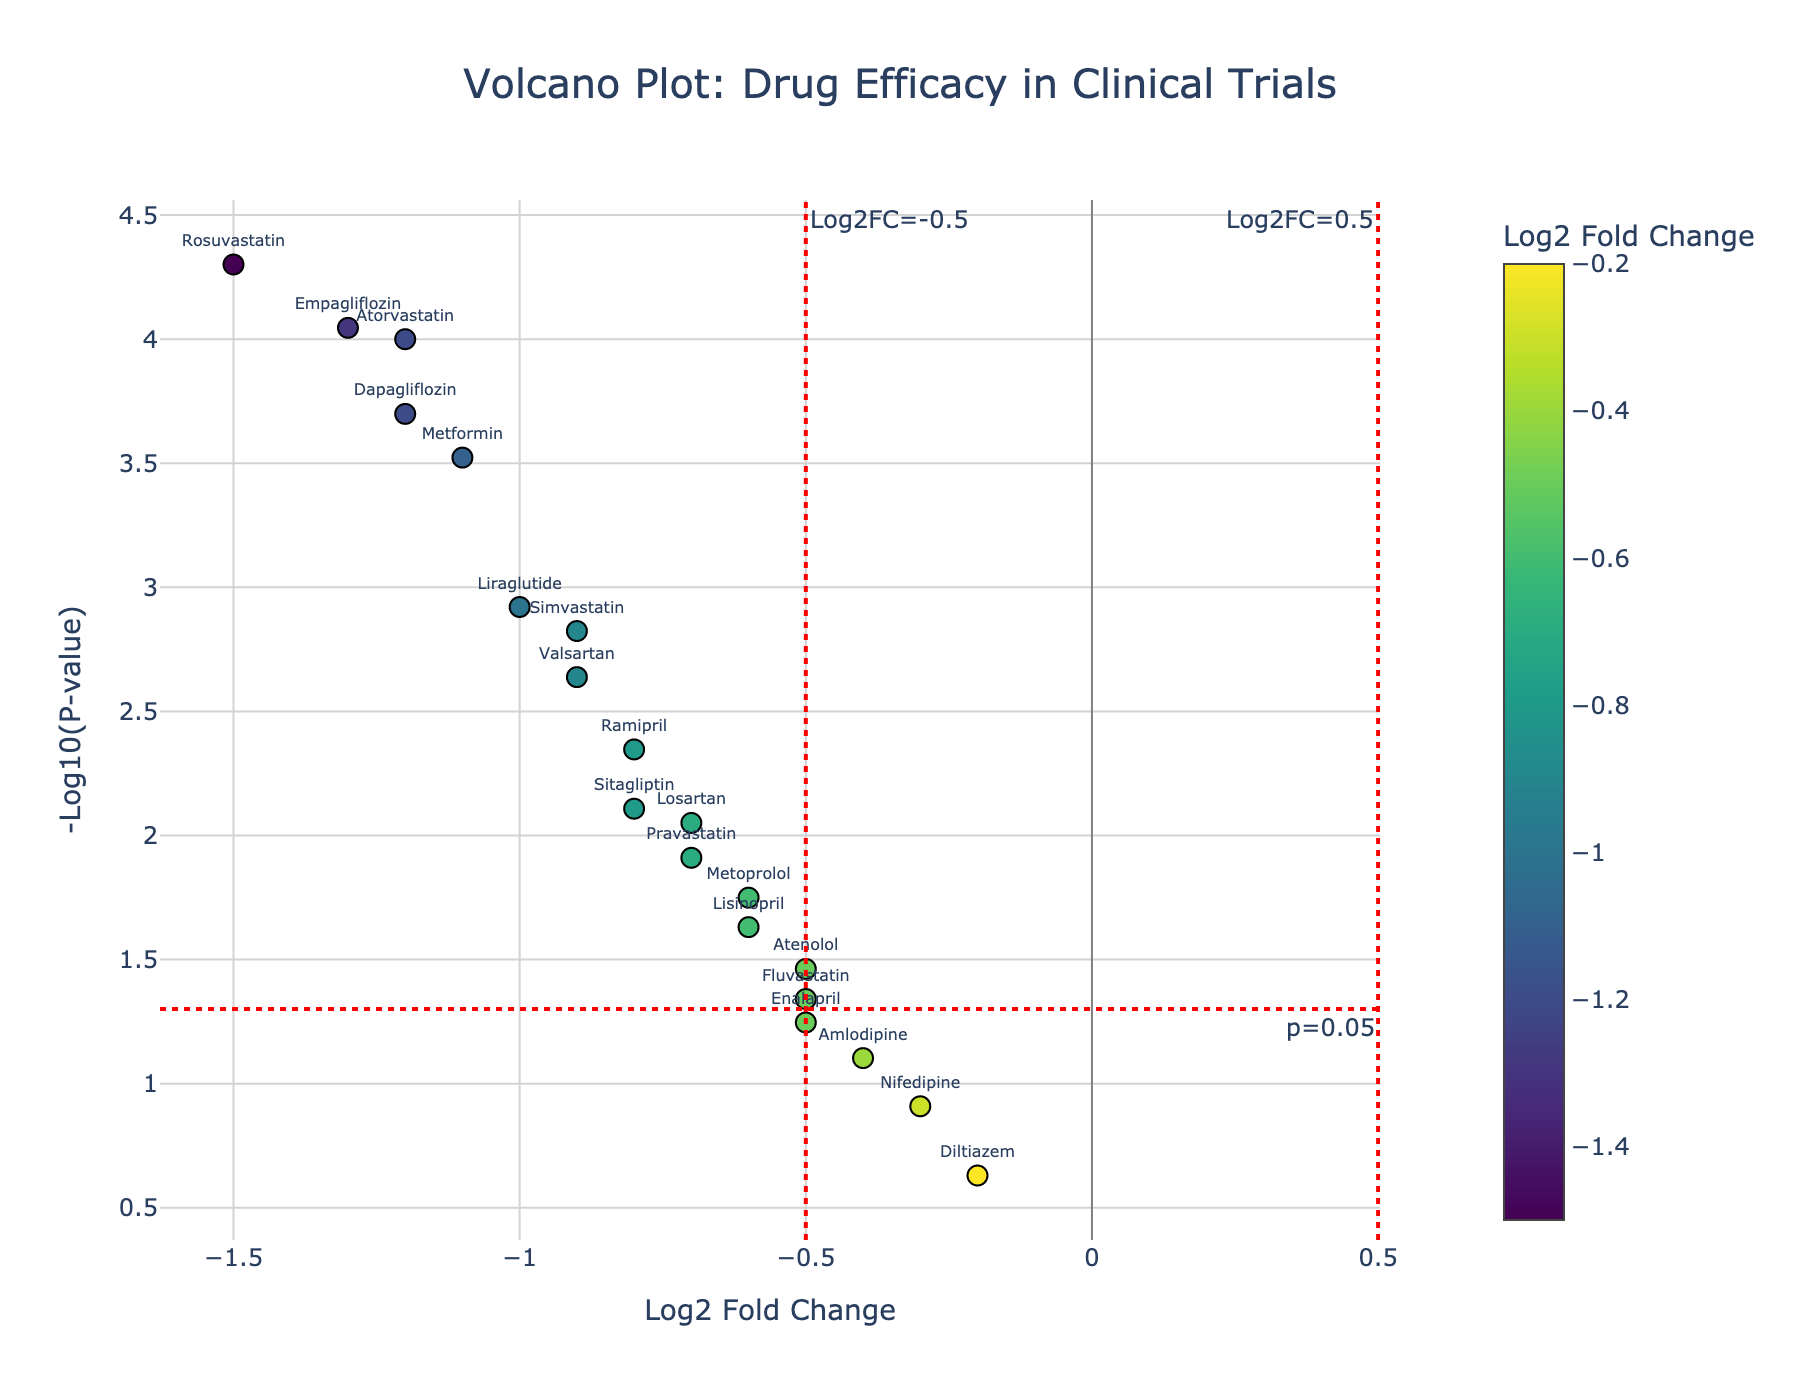What is the title of the Volcano Plot? The title is displayed prominently at the top of the plot. It reads "Volcano Plot: Drug Efficacy in Clinical Trials".
Answer: Volcano Plot: Drug Efficacy in Clinical Trials How many drugs are represented in the plot? Count the number of data points or the number of drug names shown in the plot. There are 20 drugs.
Answer: 20 Which drug has the highest -log10(p-value)? Identify the data point that is highest on the y-axis. Rosuvastatin has the highest -log10(p-value).
Answer: Rosuvastatin What is the log2 fold change for Rosuvastatin, and what does it indicate about its drug efficacy? Locate Rosuvastatin on the plot, its log2 fold change is -1.5. A negative fold-change value indicates a decrease in response.
Answer: -1.5, decrease Which drug has the lowest -log10(p-value) amongst those shown in the plot? Identify the data point that is lowest on the y-axis. Diltiazem has the lowest -log10(p-value).
Answer: Diltiazem Which drugs have a statistically significant p-value threshold of 0.05? Look for drugs that are above the horizontal red dashed line indicating p=0.05. These include Atorvastatin, Simvastatin, Rosuvastatin, Metformin, Sitagliptin, Empagliflozin, Dapagliflozin, Lisinopril, Ramipril, Valsartan, Losartan, Metoprolol, and Atenolol.
Answer: Atorvastatin, Simvastatin, Rosuvastatin, Metformin, Sitagliptin, Empagliflozin, Dapagliflozin, Lisinopril, Ramipril, Valsartan, Losartan, Metoprolol, Atenolol Compare the log2 fold changes of Atorvastatin and Simvastatin. Which one shows a greater change and in what direction? Find the log2 fold changes for both drugs, Atorvastatin is -1.2 and Simvastatin is -0.9. Atorvastatin shows a greater change in the negative direction.
Answer: Atorvastatin, negative What does a -log10(p-value) above 1.3 indicate, and which drugs have this? A -log10(p-value) above 1.3 indicates a p-value less than 0.05, showing statistical significance. Drugs with this are Atorvastatin, Simvastatin, Rosuvastatin, Metformin, Sitagliptin, Empagliflozin, Liraglutide, Dapagliflozin, Lisinopril, Ramipril, Valsartan, and Metoprolol.
Answer: Atorvastatin, Simvastatin, Rosuvastatin, Metformin, Sitagliptin, Empagliflozin, Liraglutide, Dapagliflozin, Lisinopril, Ramipril, Valsartan, Metoprolol Which drugs have log2 fold changes less than -1, and what does this mean? Identify drugs with log2 fold changes less than -1 on the plot. These are Atorvastatin, Rosuvastatin, Metformin, Empagliflozin, and Dapagliflozin. It means all these drugs have a more than 50% decrease in response.
Answer: Atorvastatin, Rosuvastatin, Metformin, Empagliflozin, Dapagliflozin What is the relationship between log2 fold change and p-value in the context of this plot? Generally, drugs with greater log2 fold changes (either positive or negative) tend to have lower p-values (higher -log10(p-values)), suggesting more significant results.
Answer: Greater log2 fold changes tend to have lower p-values 